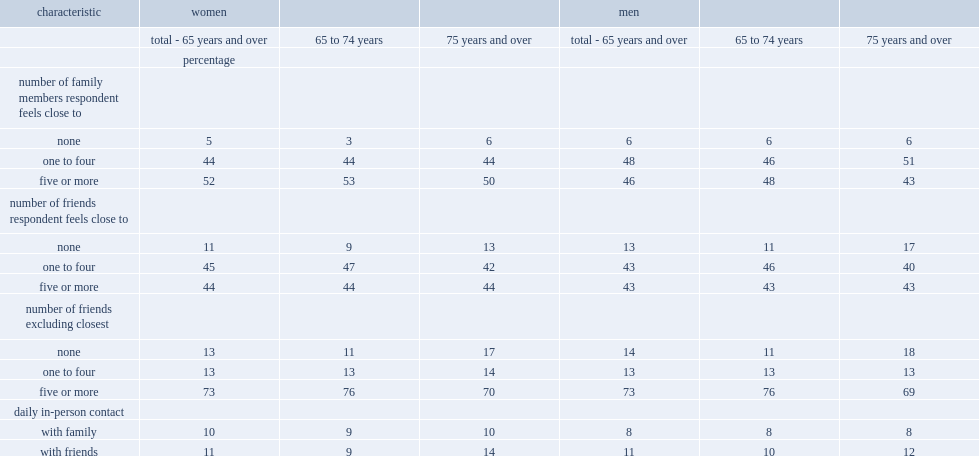Could you parse the entire table as a dict? {'header': ['characteristic', 'women', '', '', 'men', '', ''], 'rows': [['', 'total - 65 years and over', '65 to 74 years', '75 years and over', 'total - 65 years and over', '65 to 74 years', '75 years and over'], ['', 'percentage', '', '', '', '', ''], ['number of family members respondent feels close to', '', '', '', '', '', ''], ['none', '5', '3', '6', '6', '6', '6'], ['one to four', '44', '44', '44', '48', '46', '51'], ['five or more', '52', '53', '50', '46', '48', '43'], ['number of friends respondent feels close to', '', '', '', '', '', ''], ['none', '11', '9', '13', '13', '11', '17'], ['one to four', '45', '47', '42', '43', '46', '40'], ['five or more', '44', '44', '44', '43', '43', '43'], ['number of friends excluding closest', '', '', '', '', '', ''], ['none', '13', '11', '17', '14', '11', '18'], ['one to four', '13', '13', '14', '13', '13', '13'], ['five or more', '73', '76', '70', '73', '76', '69'], ['daily in-person contact', '', '', '', '', '', ''], ['with family', '10', '9', '10', '8', '8', '8'], ['with friends', '11', '9', '14', '11', '10', '12']]} What are the percentage of women aged 65 to 74 and women aged 75 and over reported having no close family members respectively. 3.0 6.0. Which is more of having daily in-person contact with friends,older senior women or women aged 65 to 74. 75 years and over. Which sex is less likely having no close family members,senior men or senior women? Men. Which is less likely to report having daily in-person contact with a family member,senior men or senior women. Men. 